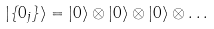Convert formula to latex. <formula><loc_0><loc_0><loc_500><loc_500>\left | \left \{ 0 _ { j } \right \} \right \rangle = \left | 0 \right \rangle \otimes \left | 0 \right \rangle \otimes \left | 0 \right \rangle \otimes \dots</formula> 